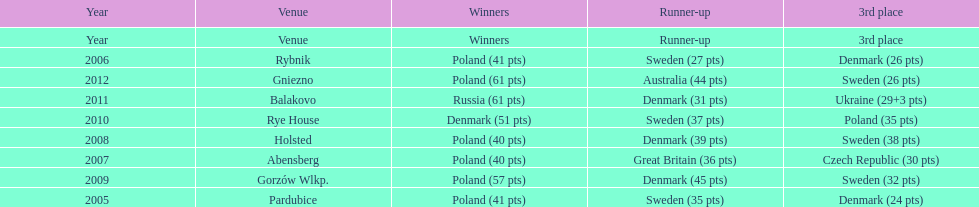Which team has the most third place wins in the speedway junior world championship between 2005 and 2012? Sweden. 